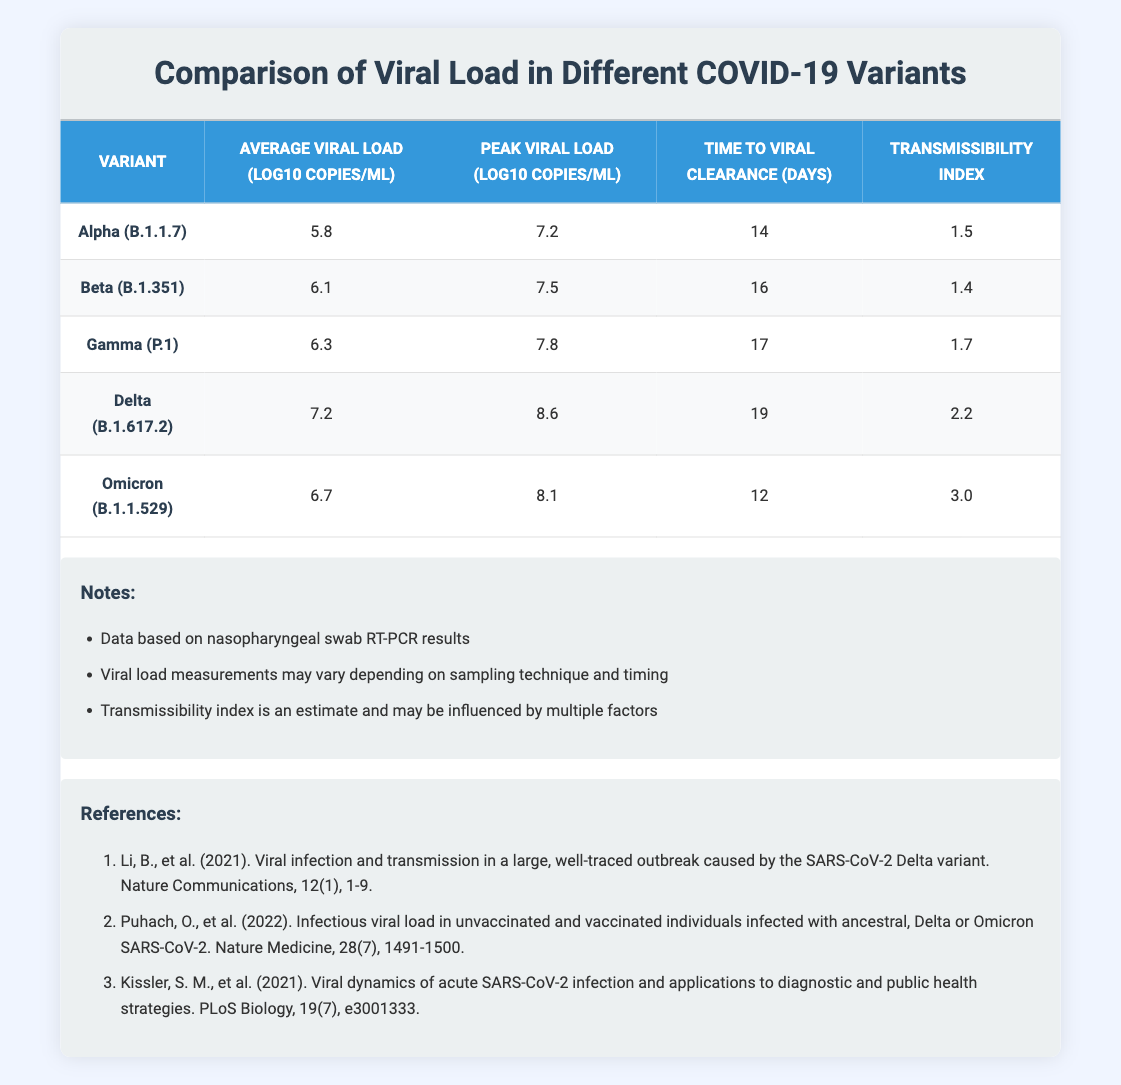What is the average viral load for the Delta variant? The average viral load for the Delta (B.1.617.2) variant is provided in the table under the "Average Viral Load" column. It is listed as 7.2 log10 copies/mL.
Answer: 7.2 log10 copies/mL Which variant has the longest time to viral clearance? To determine which variant has the longest time to viral clearance, we compare the values in the "Time to Viral Clearance" column. Delta (B.1.617.2) has a time of 19 days, which is the highest among all listed variants.
Answer: Delta (B.1.617.2) Is the transmissibility index of Omicron higher than that of Alpha? By checking the "Transmissibility Index" column, Omicron (B.1.1.529) has a value of 3.0 while Alpha (B.1.1.7) has a value of 1.5. Since 3.0 is greater than 1.5, we can conclude that Omicron's transmissibility index is higher.
Answer: Yes What is the peak viral load for the Gamma variant? The peak viral load for the Gamma (P.1) variant can be found in the "Peak Viral Load" column. It is recorded as 7.8 log10 copies/mL.
Answer: 7.8 log10 copies/mL Calculate the difference in average viral load between Delta and Omicron. To find the difference, we subtract the average viral load of Omicron (6.7 log10 copies/mL) from Delta (7.2 log10 copies/mL). The calculation is 7.2 - 6.7 = 0.5 log10 copies/mL.
Answer: 0.5 log10 copies/mL Which variants have an average viral load greater than 6.0 log10 copies/mL? By reviewing the "Average Viral Load" column, we see that the variants Beta (6.1), Gamma (6.3), Delta (7.2), and Omicron (6.7) have values greater than 6.0 log10 copies/mL, totaling four variants.
Answer: Beta, Gamma, Delta, Omicron Does the Beta variant have a higher peak viral load than the Alpha variant? The peak viral load values are compared: Beta (7.5 log10 copies/mL) and Alpha (7.2 log10 copies/mL). Since 7.5 is greater than 7.2, Beta does indeed have a higher peak viral load.
Answer: Yes What is the average time to viral clearance for all variants combined? To get the average time to viral clearance, we add the times: 14 + 16 + 17 + 19 + 12 = 78 days, and divide by 5 (the number of variants), yielding an average of 78/5 = 15.6 days.
Answer: 15.6 days 